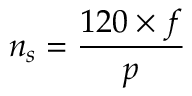Convert formula to latex. <formula><loc_0><loc_0><loc_500><loc_500>n _ { s } = { \frac { 1 2 0 \times { f } } { p } }</formula> 